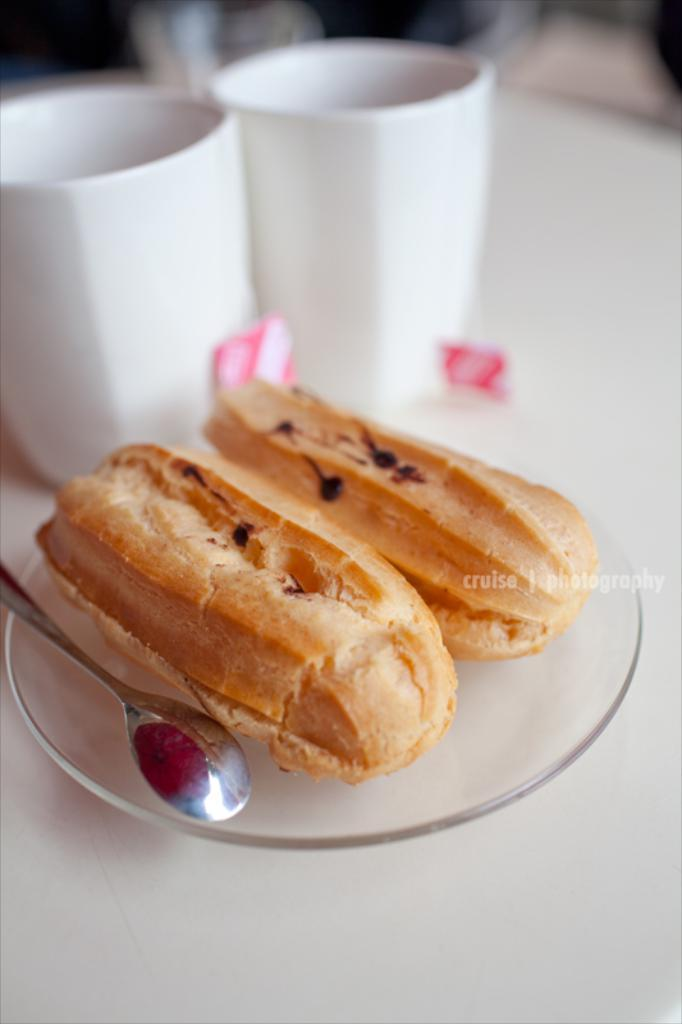What is the main object in the center of the image? There is a table in the center of the image. What items can be seen on the table? There are glasses and a plate containing food on the table. What utensil is present on the plate? A spoon is present on the plate. Is there any text visible on the plate? Yes, there is some text visible on the plate. How would you describe the top part of the image? The top part of the image is blurry. What mark can be seen on the edge of the plate in the image? There is no mark visible on the edge of the plate in the image. 